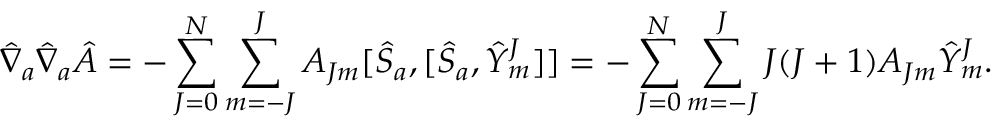<formula> <loc_0><loc_0><loc_500><loc_500>{ \hat { \nabla } } _ { a } { \hat { \nabla } } _ { a } { \hat { A } } = - \sum _ { J = 0 } ^ { N } \sum _ { m = - J } ^ { J } A _ { J m } [ { \hat { S } } _ { a } , [ { \hat { S } } _ { a } , { \hat { Y } } _ { m } ^ { J } ] ] = - \sum _ { J = 0 } ^ { N } \sum _ { m = - J } ^ { J } J ( J + 1 ) A _ { J m } { \hat { Y } } _ { m } ^ { J } .</formula> 